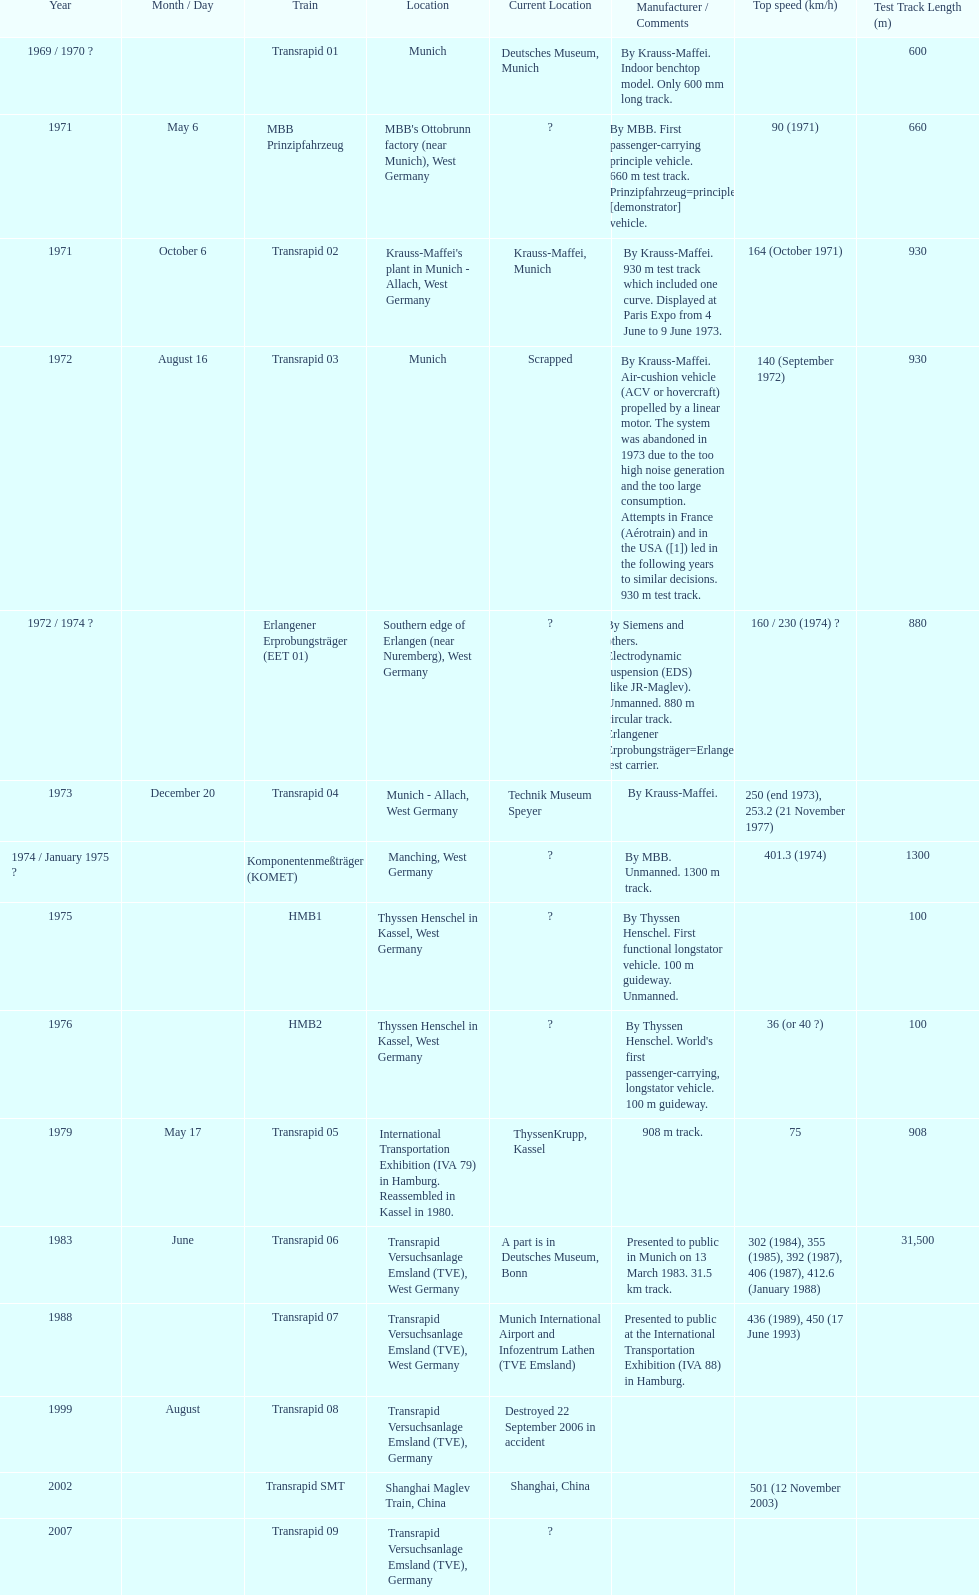High noise generation and too large consumption led to what train being scrapped? Transrapid 03. 